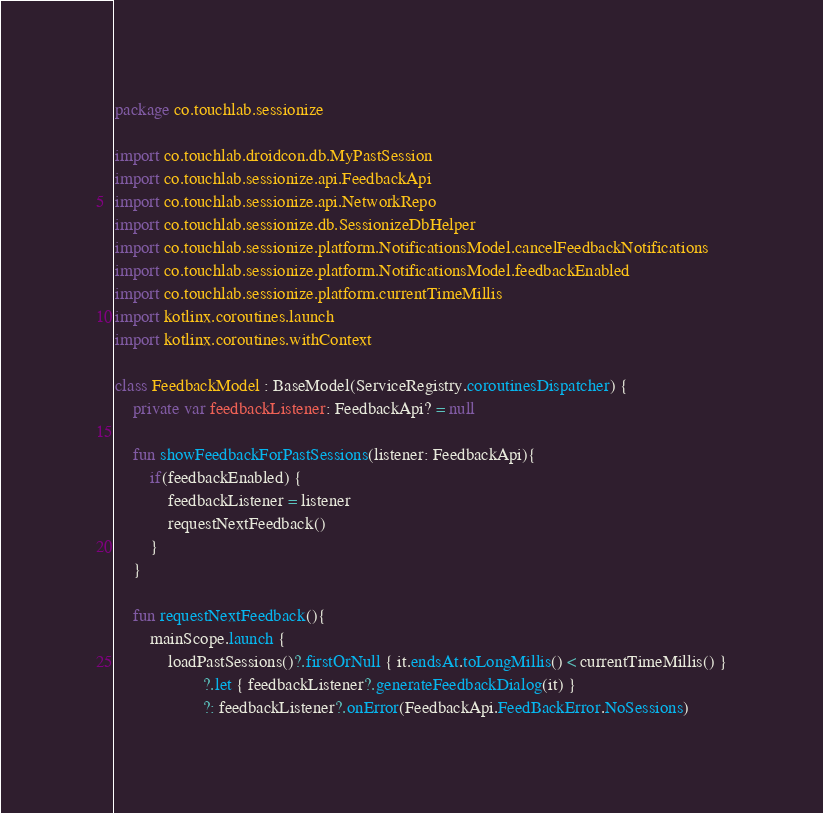Convert code to text. <code><loc_0><loc_0><loc_500><loc_500><_Kotlin_>package co.touchlab.sessionize

import co.touchlab.droidcon.db.MyPastSession
import co.touchlab.sessionize.api.FeedbackApi
import co.touchlab.sessionize.api.NetworkRepo
import co.touchlab.sessionize.db.SessionizeDbHelper
import co.touchlab.sessionize.platform.NotificationsModel.cancelFeedbackNotifications
import co.touchlab.sessionize.platform.NotificationsModel.feedbackEnabled
import co.touchlab.sessionize.platform.currentTimeMillis
import kotlinx.coroutines.launch
import kotlinx.coroutines.withContext

class FeedbackModel : BaseModel(ServiceRegistry.coroutinesDispatcher) {
    private var feedbackListener: FeedbackApi? = null

    fun showFeedbackForPastSessions(listener: FeedbackApi){
        if(feedbackEnabled) {
            feedbackListener = listener
            requestNextFeedback()
        }
    }

    fun requestNextFeedback(){
        mainScope.launch {
            loadPastSessions()?.firstOrNull { it.endsAt.toLongMillis() < currentTimeMillis() }
                    ?.let { feedbackListener?.generateFeedbackDialog(it) }
                    ?: feedbackListener?.onError(FeedbackApi.FeedBackError.NoSessions)</code> 